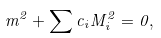<formula> <loc_0><loc_0><loc_500><loc_500>m ^ { 2 } + \sum c _ { i } M _ { i } ^ { 2 } = 0 ,</formula> 